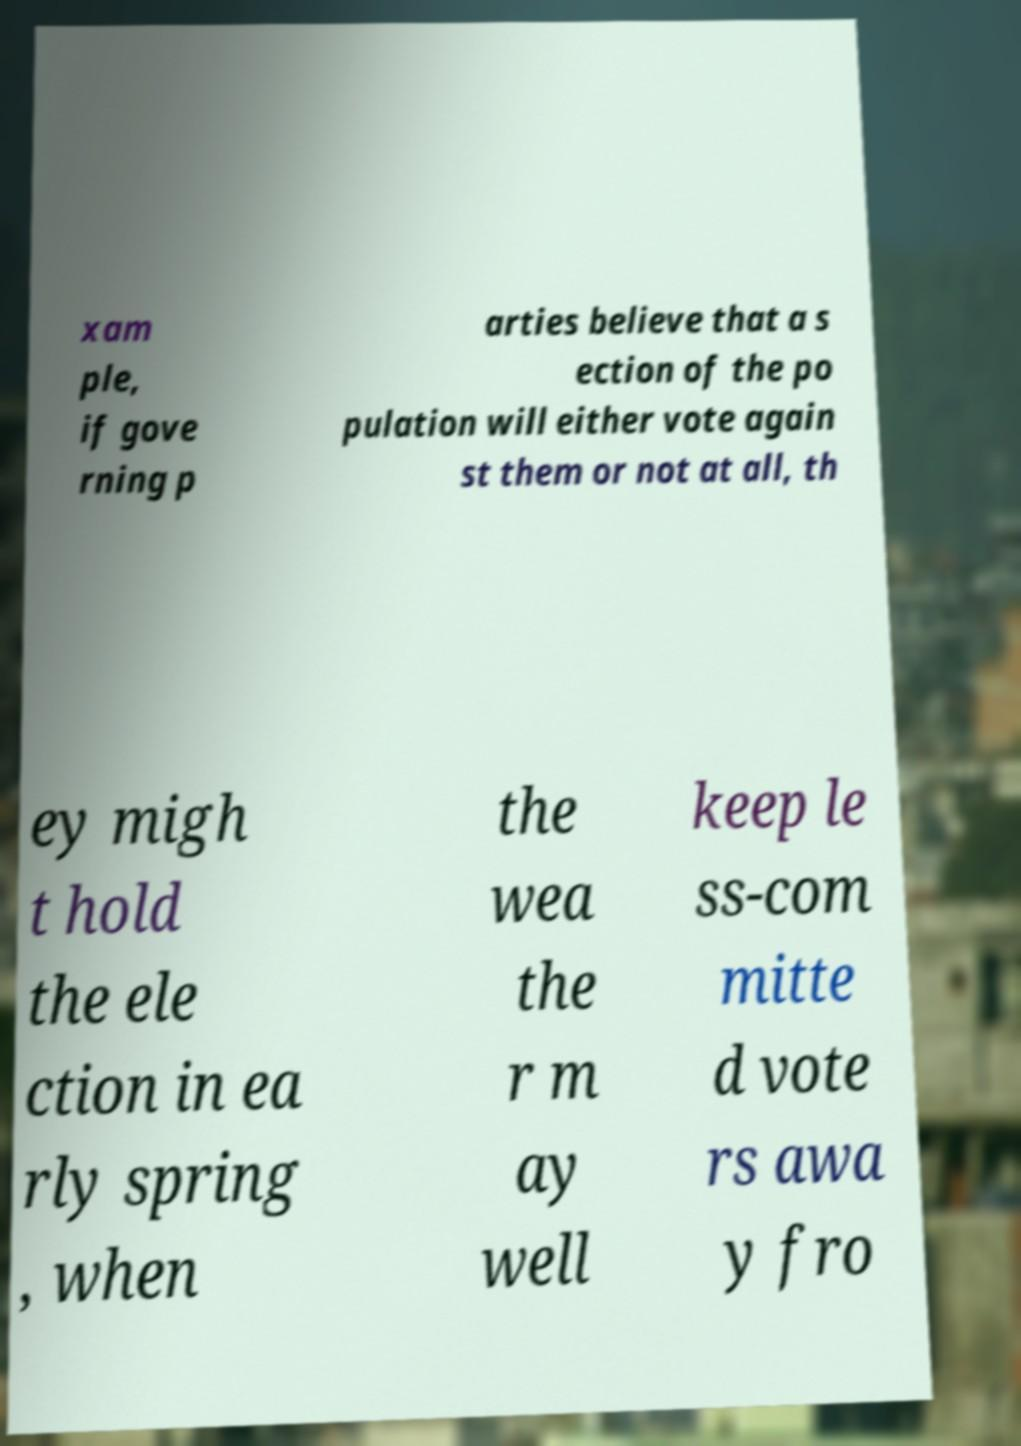Could you assist in decoding the text presented in this image and type it out clearly? xam ple, if gove rning p arties believe that a s ection of the po pulation will either vote again st them or not at all, th ey migh t hold the ele ction in ea rly spring , when the wea the r m ay well keep le ss-com mitte d vote rs awa y fro 